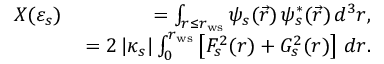<formula> <loc_0><loc_0><loc_500><loc_500>\begin{array} { r l r } & { X ( \varepsilon _ { s } ) \, } & { = \int _ { r \leq r _ { w s } } \psi _ { s } ( \vec { r } ) \, \psi _ { s } ^ { * } ( \vec { r } ) \, d ^ { 3 } r , } \\ & { = 2 \, | \kappa _ { s } | \int _ { 0 } ^ { r _ { w s } } \left [ F _ { s } ^ { 2 } ( r ) + G _ { s } ^ { 2 } ( r ) \right ] \, d r . } \end{array}</formula> 